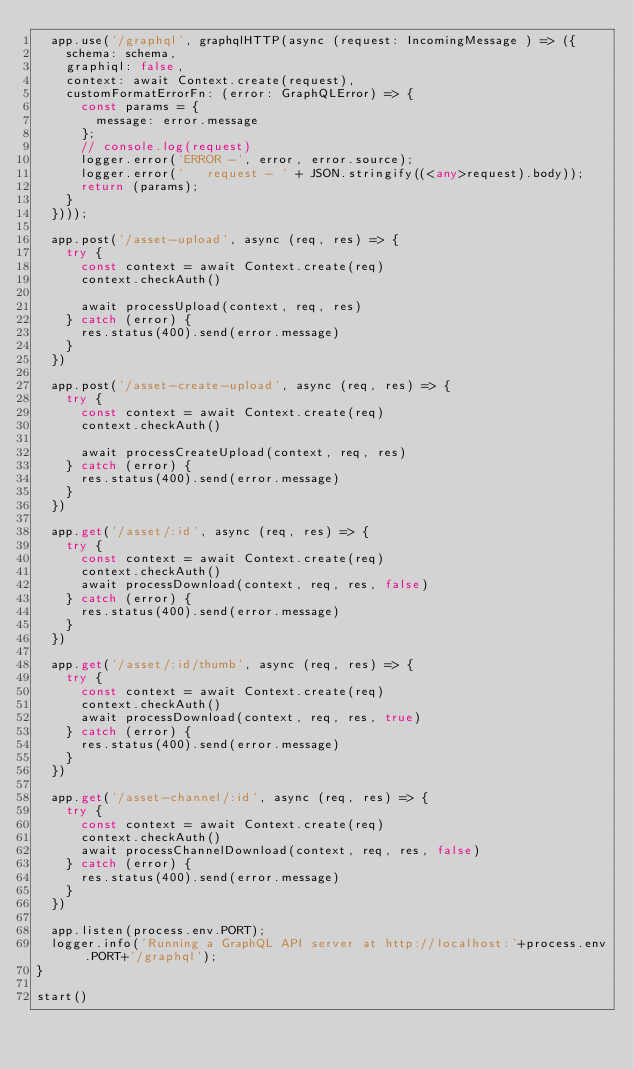<code> <loc_0><loc_0><loc_500><loc_500><_TypeScript_>  app.use('/graphql', graphqlHTTP(async (request: IncomingMessage ) => ({
    schema: schema,
    graphiql: false,
    context: await Context.create(request),
    customFormatErrorFn: (error: GraphQLError) => {
      const params = {
        message: error.message
      };
      // console.log(request)
      logger.error('ERROR -', error, error.source);
      logger.error('   request - ' + JSON.stringify((<any>request).body));
      return (params);
    }
  })));

  app.post('/asset-upload', async (req, res) => {
    try {
      const context = await Context.create(req)
      context.checkAuth()

      await processUpload(context, req, res)
    } catch (error) {
      res.status(400).send(error.message)
    }
  })

  app.post('/asset-create-upload', async (req, res) => {
    try {
      const context = await Context.create(req)
      context.checkAuth()

      await processCreateUpload(context, req, res)
    } catch (error) {
      res.status(400).send(error.message)
    }
  })

  app.get('/asset/:id', async (req, res) => {
    try {
      const context = await Context.create(req)
      context.checkAuth()
      await processDownload(context, req, res, false)
    } catch (error) {
      res.status(400).send(error.message)
    }
  })

  app.get('/asset/:id/thumb', async (req, res) => {
    try {
      const context = await Context.create(req)
      context.checkAuth()
      await processDownload(context, req, res, true)
    } catch (error) {
      res.status(400).send(error.message)
    }
  })

  app.get('/asset-channel/:id', async (req, res) => {
    try {
      const context = await Context.create(req)
      context.checkAuth()
      await processChannelDownload(context, req, res, false)
    } catch (error) {
      res.status(400).send(error.message)
    }
  })

  app.listen(process.env.PORT);
  logger.info('Running a GraphQL API server at http://localhost:'+process.env.PORT+'/graphql');
}

start()</code> 